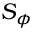<formula> <loc_0><loc_0><loc_500><loc_500>S _ { \phi }</formula> 